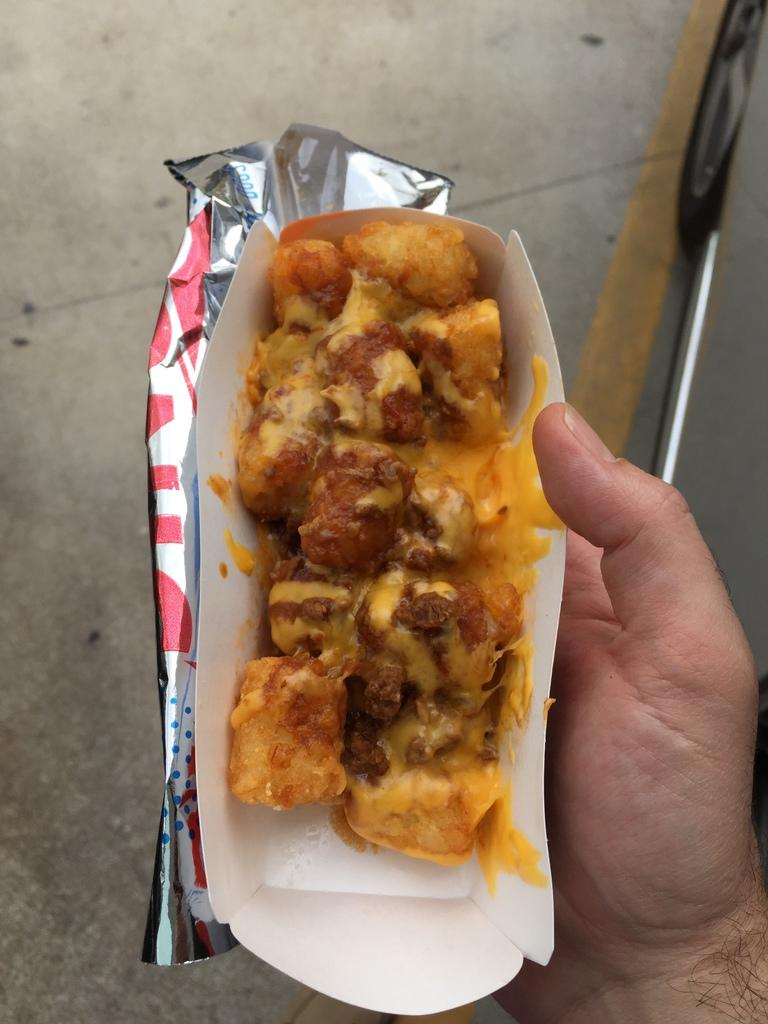What is present in the image? There is a person in the image. What is the person holding in the image? The person is holding an edible. Can you describe the placement of the edible in the image? The edible is placed on an object in the person's hand. What color is the pig in the image? There is no pig present in the image. What type of yam is being held by the person in the image? There is no yam present in the image; the person is holding an edible, but its specific type is not mentioned. 